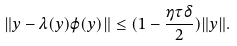Convert formula to latex. <formula><loc_0><loc_0><loc_500><loc_500>\| y - \lambda ( y ) \varphi ( y ) \| \leq ( 1 - \frac { \eta \tau \delta } { 2 } ) \| y \| .</formula> 